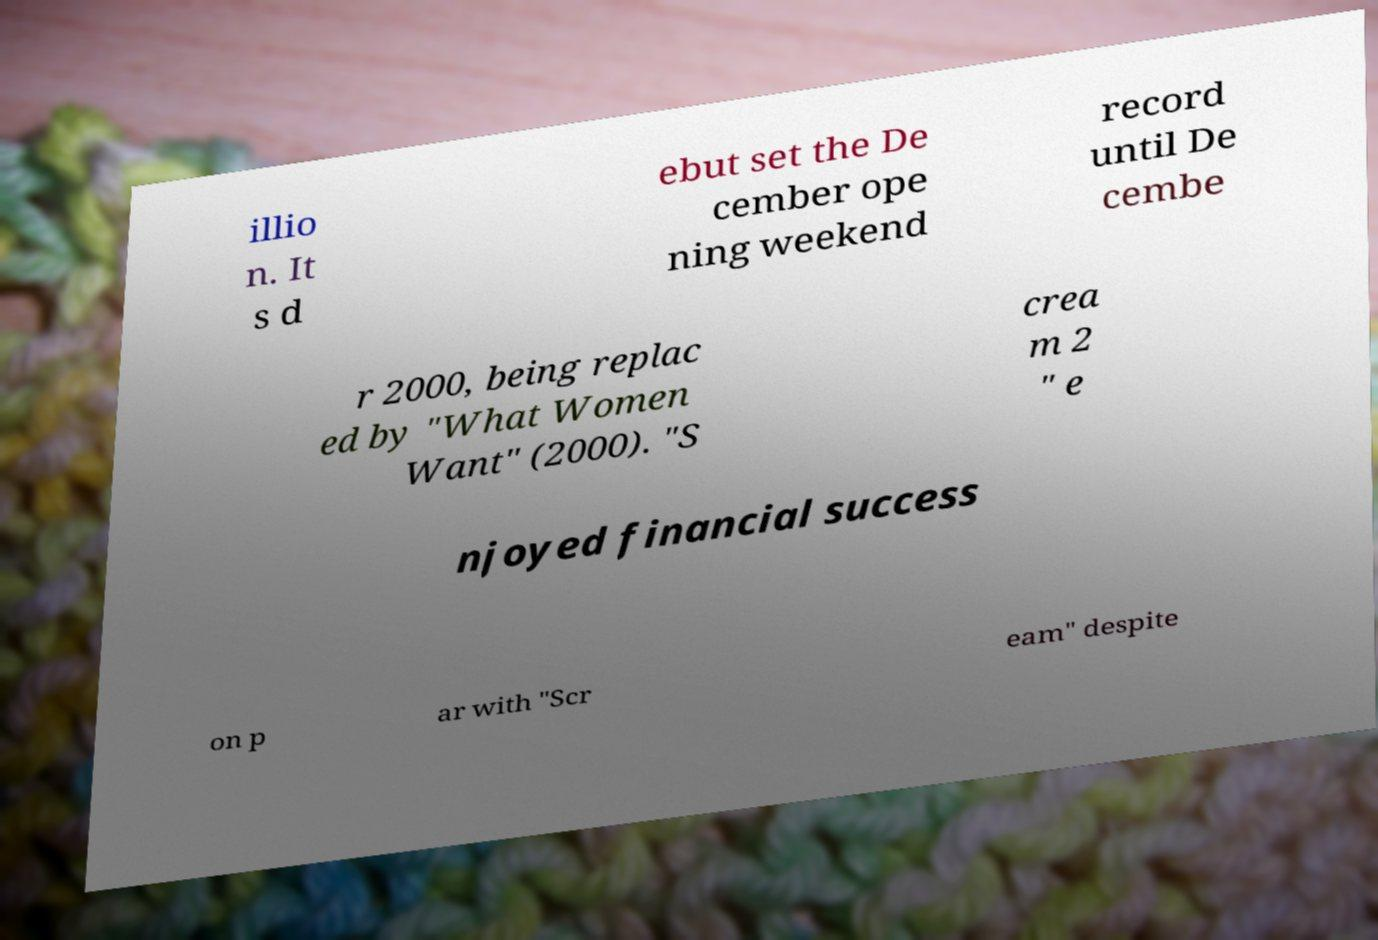I need the written content from this picture converted into text. Can you do that? illio n. It s d ebut set the De cember ope ning weekend record until De cembe r 2000, being replac ed by "What Women Want" (2000). "S crea m 2 " e njoyed financial success on p ar with "Scr eam" despite 